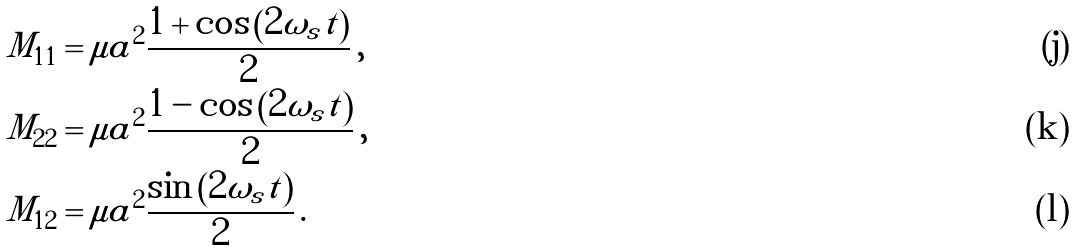<formula> <loc_0><loc_0><loc_500><loc_500>M _ { 1 1 } & = \mu a ^ { 2 } \frac { 1 + \cos \left ( 2 \omega _ { s } t \right ) } { 2 } \, , \\ M _ { 2 2 } & = \mu a ^ { 2 } \frac { 1 - \cos \left ( 2 \omega _ { s } t \right ) } { 2 } \, , \\ M _ { 1 2 } & = \mu a ^ { 2 } \frac { \sin \left ( 2 \omega _ { s } t \right ) } { 2 } \, .</formula> 